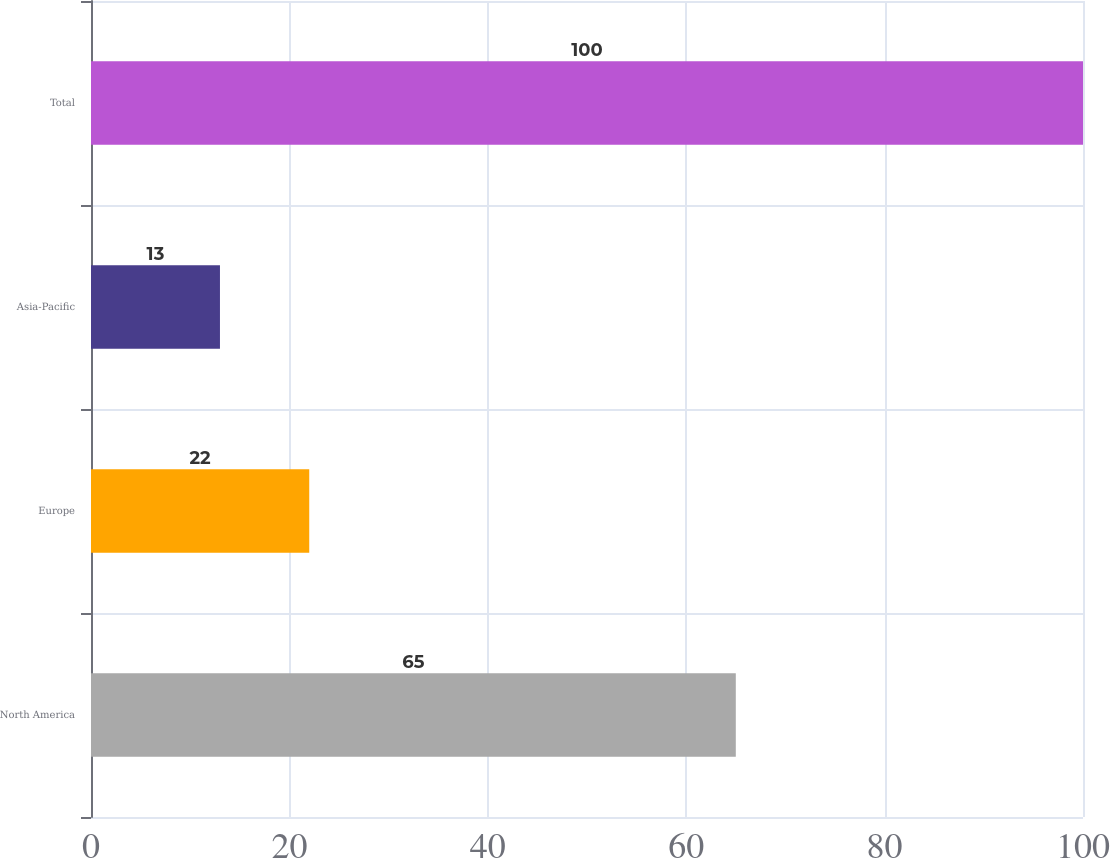Convert chart. <chart><loc_0><loc_0><loc_500><loc_500><bar_chart><fcel>North America<fcel>Europe<fcel>Asia-Pacific<fcel>Total<nl><fcel>65<fcel>22<fcel>13<fcel>100<nl></chart> 